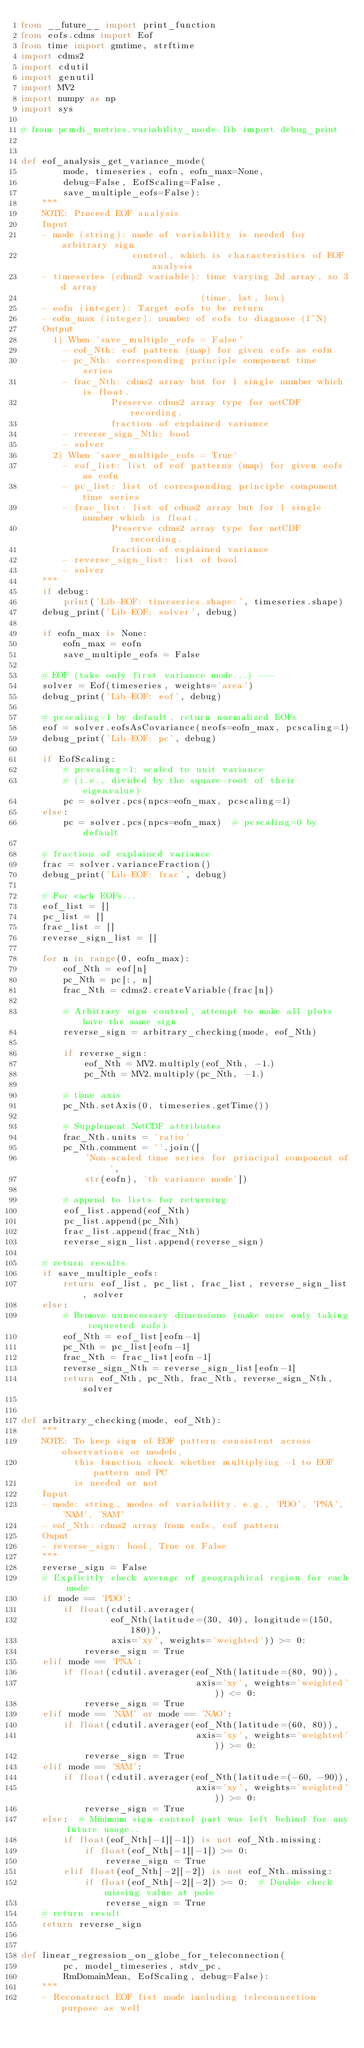Convert code to text. <code><loc_0><loc_0><loc_500><loc_500><_Python_>from __future__ import print_function
from eofs.cdms import Eof
from time import gmtime, strftime
import cdms2
import cdutil
import genutil
import MV2
import numpy as np
import sys

# from pcmdi_metrics.variability_mode.lib import debug_print


def eof_analysis_get_variance_mode(
        mode, timeseries, eofn, eofn_max=None,
        debug=False, EofScaling=False,
        save_multiple_eofs=False):
    """
    NOTE: Proceed EOF analysis
    Input
    - mode (string): mode of variability is needed for arbitrary sign
                     control, which is characteristics of EOF analysis
    - timeseries (cdms2 variable): time varying 2d array, so 3d array
                                  (time, lat, lon)
    - eofn (integer): Target eofs to be return
    - eofn_max (integer): number of eofs to diagnose (1~N)
    Output
      1) When 'save_multiple_eofs = False'
        - eof_Nth: eof pattern (map) for given eofs as eofn
        - pc_Nth: corresponding principle component time series
        - frac_Nth: cdms2 array but for 1 single number which is float.
                 Preserve cdms2 array type for netCDF recording.
                 fraction of explained variance
        - reverse_sign_Nth: bool
        - solver
      2) When 'save_multiple_eofs = True'
        - eof_list: list of eof patterns (map) for given eofs as eofn
        - pc_list: list of corresponding principle component time series
        - frac_list: list of cdms2 array but for 1 single number which is float.
                 Preserve cdms2 array type for netCDF recording.
                 fraction of explained variance
        - reverse_sign_list: list of bool
        - solver
    """
    if debug:
        print('Lib-EOF: timeseries.shape:', timeseries.shape)
    debug_print('Lib-EOF: solver', debug)

    if eofn_max is None:
        eofn_max = eofn
        save_multiple_eofs = False

    # EOF (take only first variance mode...) ---
    solver = Eof(timeseries, weights='area')
    debug_print('Lib-EOF: eof', debug)

    # pcscaling=1 by default, return normalized EOFs
    eof = solver.eofsAsCovariance(neofs=eofn_max, pcscaling=1)
    debug_print('Lib-EOF: pc', debug)

    if EofScaling:
        # pcscaling=1: scaled to unit variance
        # (i.e., divided by the square-root of their eigenvalue)
        pc = solver.pcs(npcs=eofn_max, pcscaling=1)
    else:
        pc = solver.pcs(npcs=eofn_max)  # pcscaling=0 by default

    # fraction of explained variance
    frac = solver.varianceFraction()
    debug_print('Lib-EOF: frac', debug)

    # For each EOFs...
    eof_list = []
    pc_list = []
    frac_list = []
    reverse_sign_list = []

    for n in range(0, eofn_max):
        eof_Nth = eof[n]
        pc_Nth = pc[:, n]
        frac_Nth = cdms2.createVariable(frac[n])

        # Arbitrary sign control, attempt to make all plots have the same sign
        reverse_sign = arbitrary_checking(mode, eof_Nth)

        if reverse_sign:
            eof_Nth = MV2.multiply(eof_Nth, -1.)
            pc_Nth = MV2.multiply(pc_Nth, -1.)

        # time axis
        pc_Nth.setAxis(0, timeseries.getTime())

        # Supplement NetCDF attributes
        frac_Nth.units = 'ratio'
        pc_Nth.comment = ''.join([
            'Non-scaled time series for principal component of ',
            str(eofn), 'th variance mode'])

        # append to lists for returning
        eof_list.append(eof_Nth)
        pc_list.append(pc_Nth)
        frac_list.append(frac_Nth)
        reverse_sign_list.append(reverse_sign)

    # return results
    if save_multiple_eofs:
        return eof_list, pc_list, frac_list, reverse_sign_list, solver
    else:
        # Remove unnecessary dimensions (make sure only taking requested eofs)
        eof_Nth = eof_list[eofn-1]
        pc_Nth = pc_list[eofn-1]
        frac_Nth = frac_list[eofn-1]
        reverse_sign_Nth = reverse_sign_list[eofn-1]
        return eof_Nth, pc_Nth, frac_Nth, reverse_sign_Nth, solver


def arbitrary_checking(mode, eof_Nth):
    """
    NOTE: To keep sign of EOF pattern consistent across observations or models,
          this function check whether multiplying -1 to EOF pattern and PC
          is needed or not
    Input
    - mode: string, modes of variability. e.g., 'PDO', 'PNA', 'NAM', 'SAM'
    - eof_Nth: cdms2 array from eofs, eof pattern
    Ouput
    - reverse_sign: bool, True or False
    """
    reverse_sign = False
    # Explicitly check average of geographical region for each mode
    if mode == 'PDO':
        if float(cdutil.averager(
                 eof_Nth(latitude=(30, 40), longitude=(150, 180)),
                 axis='xy', weights='weighted')) >= 0:
            reverse_sign = True
    elif mode == 'PNA':
        if float(cdutil.averager(eof_Nth(latitude=(80, 90)),
                                 axis='xy', weights='weighted')) <= 0:
            reverse_sign = True
    elif mode == 'NAM' or mode == 'NAO':
        if float(cdutil.averager(eof_Nth(latitude=(60, 80)),
                                 axis='xy', weights='weighted')) >= 0:
            reverse_sign = True
    elif mode == 'SAM':
        if float(cdutil.averager(eof_Nth(latitude=(-60, -90)),
                                 axis='xy', weights='weighted')) >= 0:
            reverse_sign = True
    else:  # Minimum sign control part was left behind for any future usage..
        if float(eof_Nth[-1][-1]) is not eof_Nth.missing:
            if float(eof_Nth[-1][-1]) >= 0:
                reverse_sign = True
        elif float(eof_Nth[-2][-2]) is not eof_Nth.missing:
            if float(eof_Nth[-2][-2]) >= 0:  # Double check missing value at pole
                reverse_sign = True
    # return result
    return reverse_sign


def linear_regression_on_globe_for_teleconnection(
        pc, model_timeseries, stdv_pc,
        RmDomainMean, EofScaling, debug=False):
    """
    - Reconstruct EOF fist mode including teleconnection purpose as well</code> 